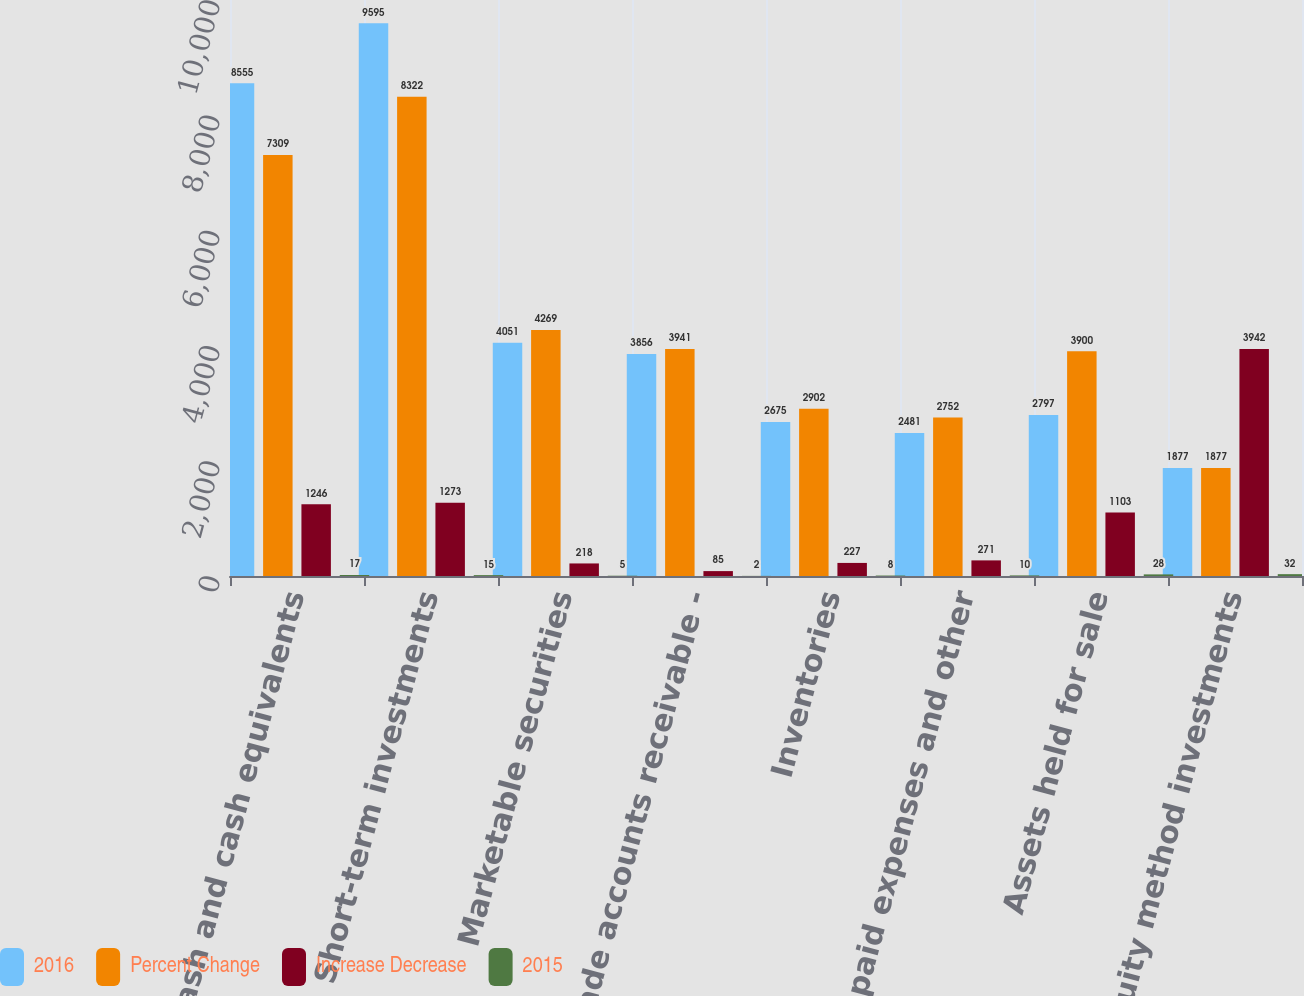<chart> <loc_0><loc_0><loc_500><loc_500><stacked_bar_chart><ecel><fcel>Cash and cash equivalents<fcel>Short-term investments<fcel>Marketable securities<fcel>Trade accounts receivable -<fcel>Inventories<fcel>Prepaid expenses and other<fcel>Assets held for sale<fcel>Equity method investments<nl><fcel>2016<fcel>8555<fcel>9595<fcel>4051<fcel>3856<fcel>2675<fcel>2481<fcel>2797<fcel>1877<nl><fcel>Percent Change<fcel>7309<fcel>8322<fcel>4269<fcel>3941<fcel>2902<fcel>2752<fcel>3900<fcel>1877<nl><fcel>Increase Decrease<fcel>1246<fcel>1273<fcel>218<fcel>85<fcel>227<fcel>271<fcel>1103<fcel>3942<nl><fcel>2015<fcel>17<fcel>15<fcel>5<fcel>2<fcel>8<fcel>10<fcel>28<fcel>32<nl></chart> 